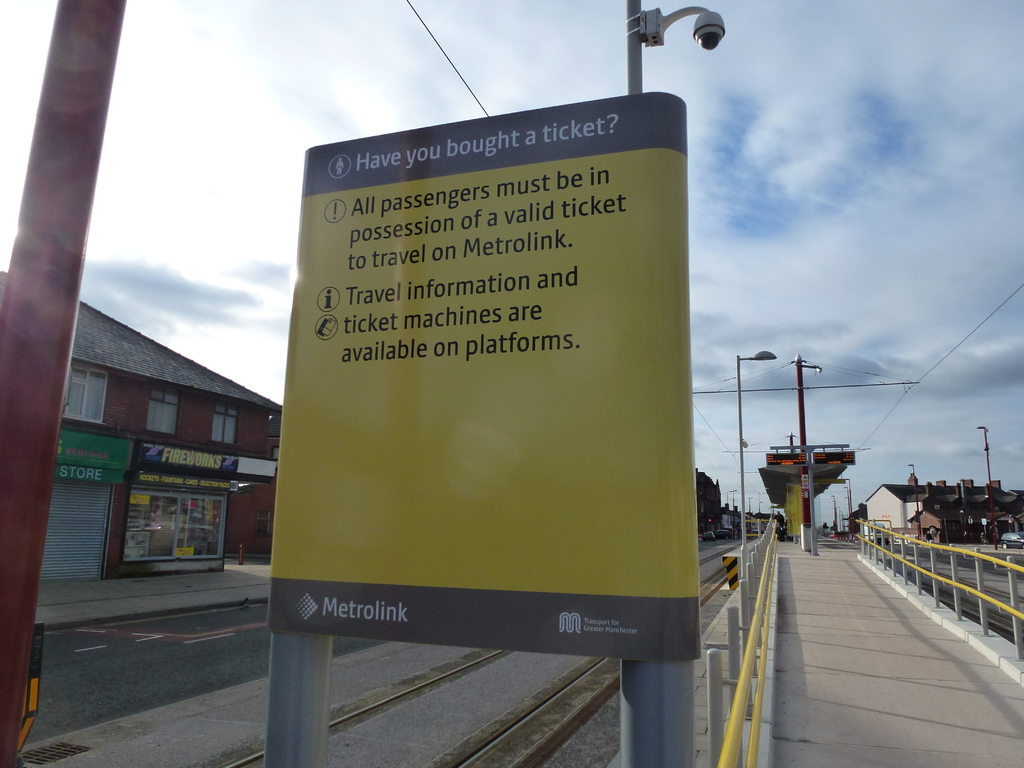What might be the significance of placing such a sign at this location? The placement of the sign at this Metrolink station serves a dual purpose. Primarily, it acts as a legal and practical reminder to ensure all passengers possess a valid ticket before traveling, helping in fare evasion prevention. Secondly, by informing about the availability of ticket machines and travel info on the platforms, it enhances passenger convenience and aids in smooth transit operations, crucial in busy urban transport systems. 